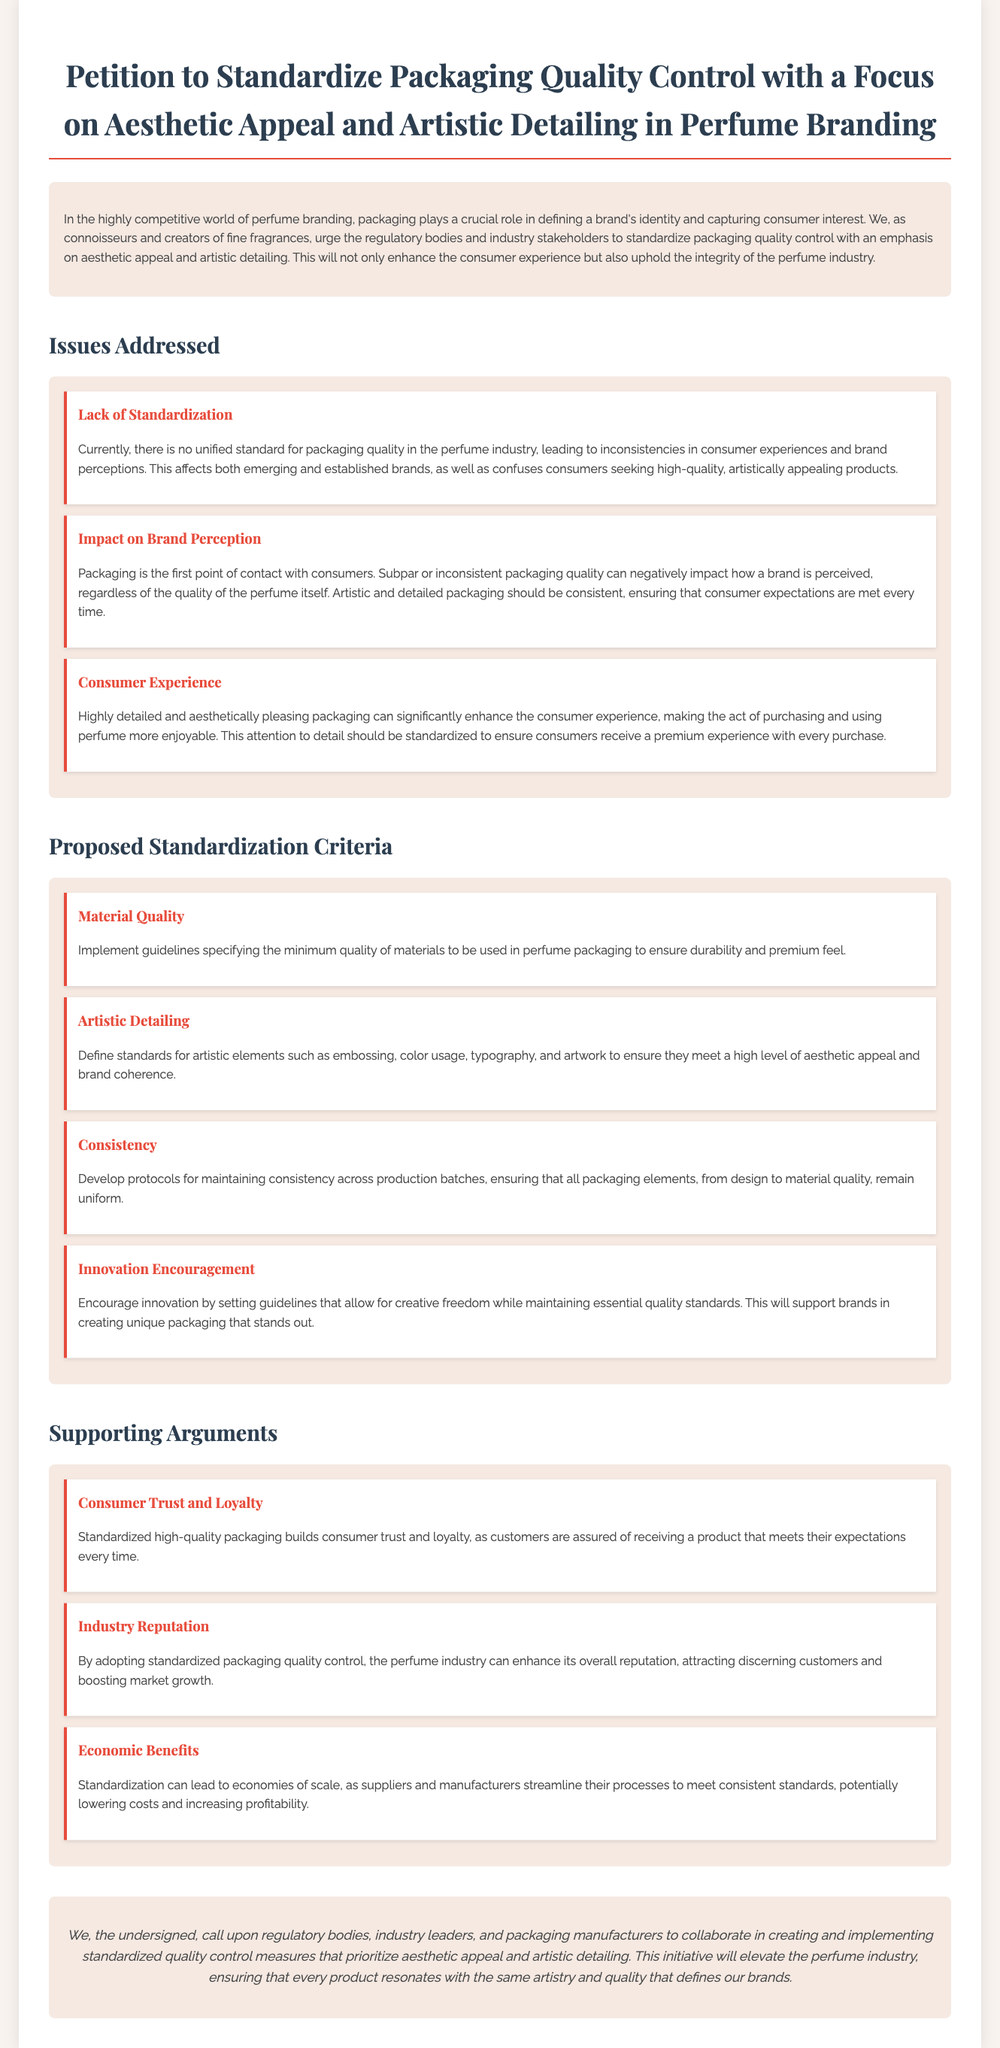What is the title of the petition? The title of the petition states its purpose clearly, which is "Petition to Standardize Packaging Quality Control with a Focus on Aesthetic Appeal and Artistic Detailing in Perfume Branding."
Answer: Petition to Standardize Packaging Quality Control with a Focus on Aesthetic Appeal and Artistic Detailing in Perfume Branding What are the three main issues addressed in the petition? The three main issues discussed are Lack of Standardization, Impact on Brand Perception, and Consumer Experience.
Answer: Lack of Standardization, Impact on Brand Perception, Consumer Experience How many proposed standardization criteria are there? The petition outlines a total of four proposed standardization criteria.
Answer: Four What is one of the proposed criteria related to the materials used in packaging? One of the proposed criteria focuses on the quality of materials used in perfume packaging to ensure durability and a premium feel.
Answer: Material Quality What is the supporting argument related to consumer behavior? The supporting argument emphasizes that standardized high-quality packaging builds consumer trust and loyalty.
Answer: Consumer Trust and Loyalty What does the conclusion call for? The conclusion calls for regulatory bodies, industry leaders, and packaging manufacturers to collaborate on creating and implementing standardized quality control measures.
Answer: Collaborate on creating and implementing standardized quality control measures Which color is prominently mentioned in the document regarding packaging? The document emphasizes the importance of color usage as part of artistic detailing in packaging standards.
Answer: Color What type of document is this? The document is categorized as a petition, which signifies a formal request for action.
Answer: Petition 